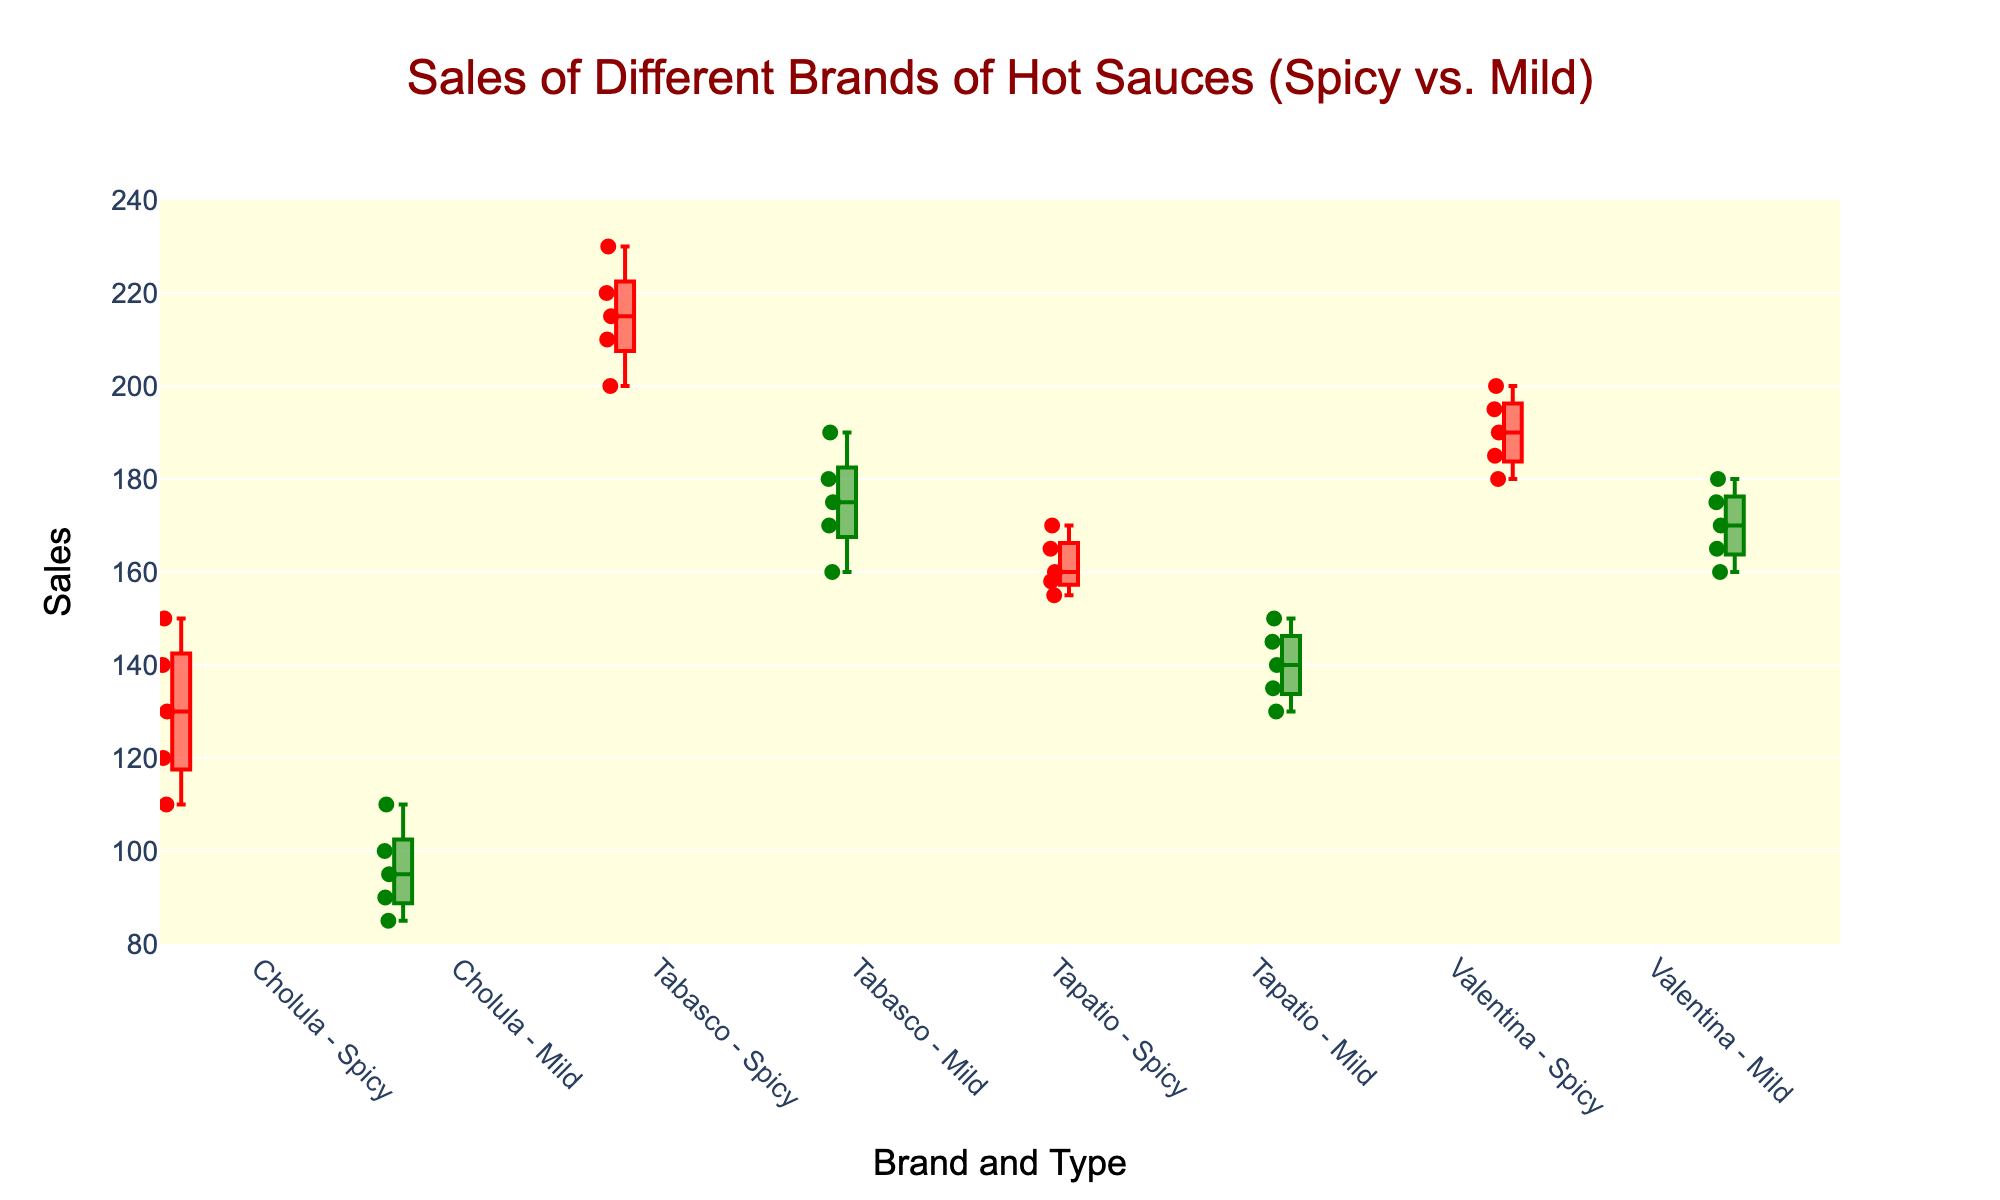Which brand has the highest median sales for spicy hot sauces? By observing the box plot for spicy hot sauces, identify the median line within each spicy box. The brand with the highest median line is Tabasco.
Answer: Tabasco What is the median sales value for mild hot sauces from Cholula? Look at Cholula's Mild box and find the line inside the box that represents the median value. For Cholula, the median line is at 95.
Answer: 95 How does the sales range of spicy Valentina differ from mild Valentina? Observe Valentina's boxes for both spicy and mild. The sales range for each brand can be seen in the box's length (from the bottom whisker to the top whisker). Spicy Valentina ranges from 180 to 200, while Mild Valentina ranges from 160 to 180.
Answer: Spicy Valentina: 180-200, Mild Valentina: 160-180 Which brand shows the least variability in sales for spicy hot sauces? In a box plot, variability is represented by the width of the boxes and the length of the whiskers. Cholula has the shortest box and whiskers for spicy hot sauces, indicating the least variability.
Answer: Cholula What is the interquartile range (IQR) for mild Tapatio hot sauces? The IQR is the difference between the first quartile (Q1) and the third quartile (Q3) of the data. In the box plot for mild Tapatio, Q1 is approximately 135 and Q3 is approximately 145. So, IQR = 145 - 135 = 10.
Answer: 10 Which spicy hot sauce brand appears to have consistently higher sales compared to its mild counterpart? Compare the median lines of both the spicy and mild boxes for each brand. Tabasco shows consistently higher sales for its spicy version compared to its mild version.
Answer: Tabasco How many data points are there for spicy Cholula hot sauce? Count the number of individual points within the spicy Cholula box plot. There are 5 data points.
Answer: 5 